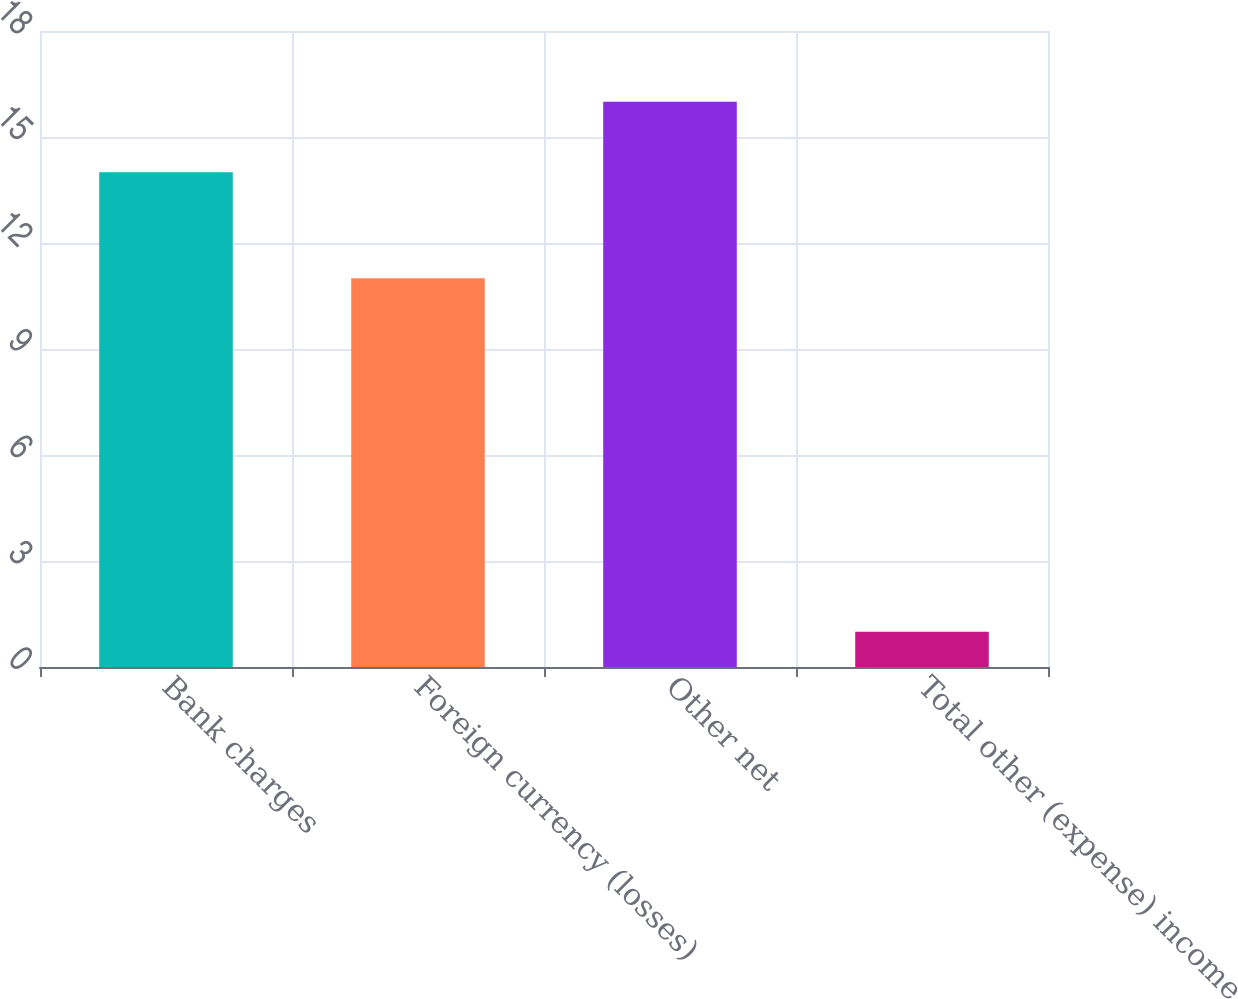<chart> <loc_0><loc_0><loc_500><loc_500><bar_chart><fcel>Bank charges<fcel>Foreign currency (losses)<fcel>Other net<fcel>Total other (expense) income<nl><fcel>14<fcel>11<fcel>16<fcel>1<nl></chart> 